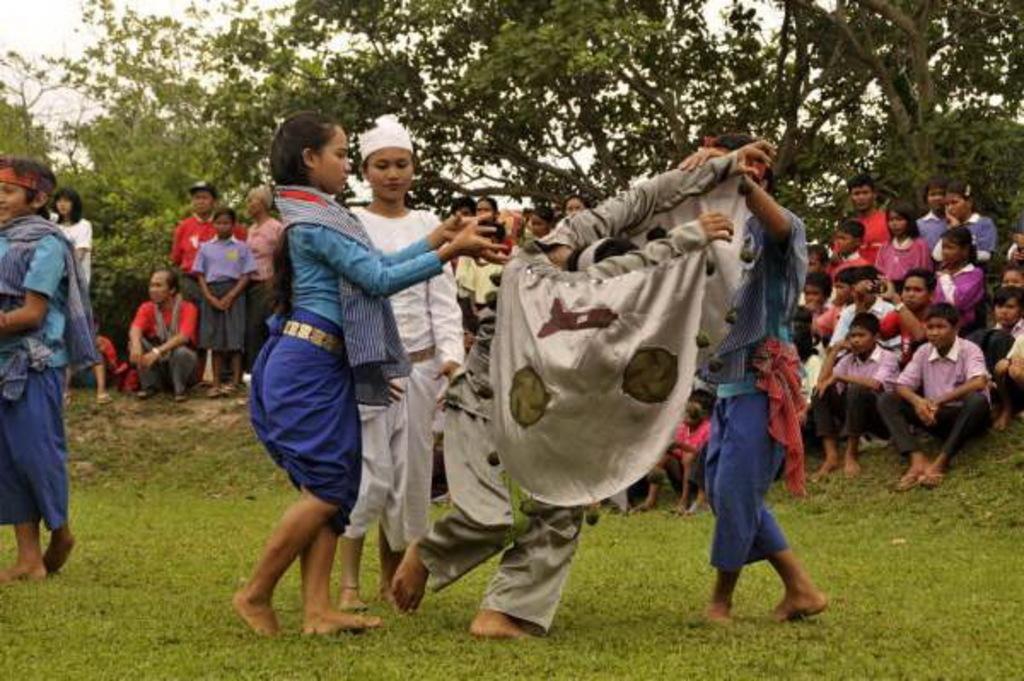Please provide a concise description of this image. In this image I can see the group of people. I can see few people are sitting on the ground and few people are standing and wearing the different color dresses. In the back there are many trees and the sky. 